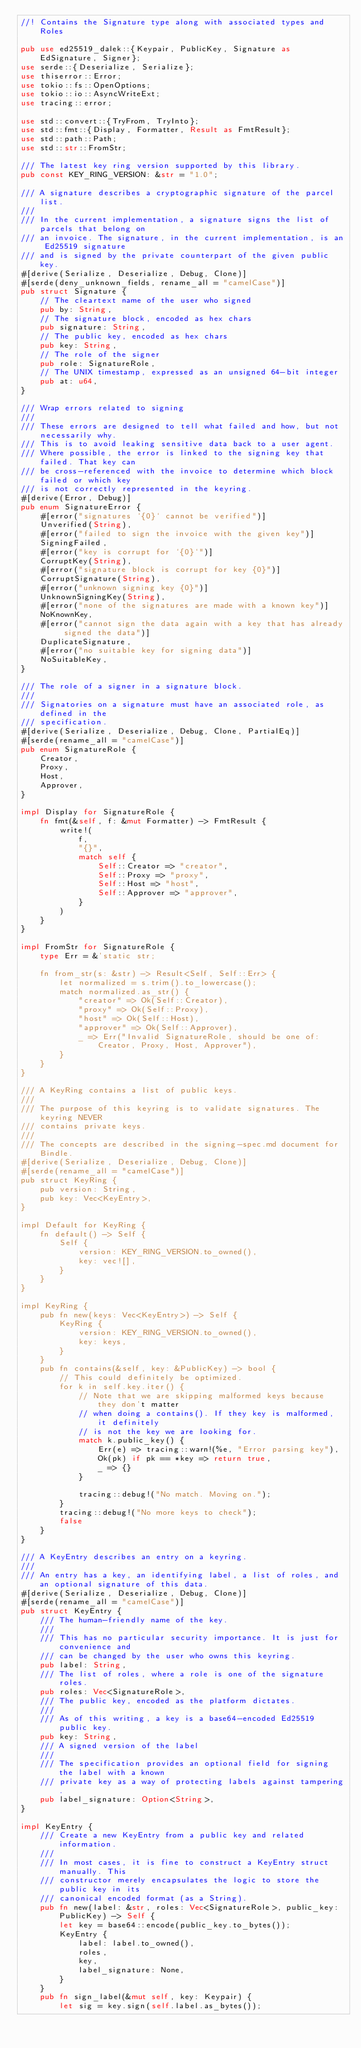Convert code to text. <code><loc_0><loc_0><loc_500><loc_500><_Rust_>//! Contains the Signature type along with associated types and Roles

pub use ed25519_dalek::{Keypair, PublicKey, Signature as EdSignature, Signer};
use serde::{Deserialize, Serialize};
use thiserror::Error;
use tokio::fs::OpenOptions;
use tokio::io::AsyncWriteExt;
use tracing::error;

use std::convert::{TryFrom, TryInto};
use std::fmt::{Display, Formatter, Result as FmtResult};
use std::path::Path;
use std::str::FromStr;

/// The latest key ring version supported by this library.
pub const KEY_RING_VERSION: &str = "1.0";

/// A signature describes a cryptographic signature of the parcel list.
///
/// In the current implementation, a signature signs the list of parcels that belong on
/// an invoice. The signature, in the current implementation, is an Ed25519 signature
/// and is signed by the private counterpart of the given public key.
#[derive(Serialize, Deserialize, Debug, Clone)]
#[serde(deny_unknown_fields, rename_all = "camelCase")]
pub struct Signature {
    // The cleartext name of the user who signed
    pub by: String,
    // The signature block, encoded as hex chars
    pub signature: String,
    // The public key, encoded as hex chars
    pub key: String,
    // The role of the signer
    pub role: SignatureRole,
    // The UNIX timestamp, expressed as an unsigned 64-bit integer
    pub at: u64,
}

/// Wrap errors related to signing
///
/// These errors are designed to tell what failed and how, but not necessarily why.
/// This is to avoid leaking sensitive data back to a user agent.
/// Where possible, the error is linked to the signing key that failed. That key can
/// be cross-referenced with the invoice to determine which block failed or which key
/// is not correctly represented in the keyring.
#[derive(Error, Debug)]
pub enum SignatureError {
    #[error("signatures `{0}` cannot be verified")]
    Unverified(String),
    #[error("failed to sign the invoice with the given key")]
    SigningFailed,
    #[error("key is corrupt for `{0}`")]
    CorruptKey(String),
    #[error("signature block is corrupt for key {0}")]
    CorruptSignature(String),
    #[error("unknown signing key {0}")]
    UnknownSigningKey(String),
    #[error("none of the signatures are made with a known key")]
    NoKnownKey,
    #[error("cannot sign the data again with a key that has already signed the data")]
    DuplicateSignature,
    #[error("no suitable key for signing data")]
    NoSuitableKey,
}

/// The role of a signer in a signature block.
///
/// Signatories on a signature must have an associated role, as defined in the
/// specification.
#[derive(Serialize, Deserialize, Debug, Clone, PartialEq)]
#[serde(rename_all = "camelCase")]
pub enum SignatureRole {
    Creator,
    Proxy,
    Host,
    Approver,
}

impl Display for SignatureRole {
    fn fmt(&self, f: &mut Formatter) -> FmtResult {
        write!(
            f,
            "{}",
            match self {
                Self::Creator => "creator",
                Self::Proxy => "proxy",
                Self::Host => "host",
                Self::Approver => "approver",
            }
        )
    }
}

impl FromStr for SignatureRole {
    type Err = &'static str;

    fn from_str(s: &str) -> Result<Self, Self::Err> {
        let normalized = s.trim().to_lowercase();
        match normalized.as_str() {
            "creator" => Ok(Self::Creator),
            "proxy" => Ok(Self::Proxy),
            "host" => Ok(Self::Host),
            "approver" => Ok(Self::Approver),
            _ => Err("Invalid SignatureRole, should be one of: Creator, Proxy, Host, Approver"),
        }
    }
}

/// A KeyRing contains a list of public keys.
///
/// The purpose of this keyring is to validate signatures. The keyring NEVER
/// contains private keys.
///
/// The concepts are described in the signing-spec.md document for Bindle.
#[derive(Serialize, Deserialize, Debug, Clone)]
#[serde(rename_all = "camelCase")]
pub struct KeyRing {
    pub version: String,
    pub key: Vec<KeyEntry>,
}

impl Default for KeyRing {
    fn default() -> Self {
        Self {
            version: KEY_RING_VERSION.to_owned(),
            key: vec![],
        }
    }
}

impl KeyRing {
    pub fn new(keys: Vec<KeyEntry>) -> Self {
        KeyRing {
            version: KEY_RING_VERSION.to_owned(),
            key: keys,
        }
    }
    pub fn contains(&self, key: &PublicKey) -> bool {
        // This could definitely be optimized.
        for k in self.key.iter() {
            // Note that we are skipping malformed keys because they don't matter
            // when doing a contains(). If they key is malformed, it definitely
            // is not the key we are looking for.
            match k.public_key() {
                Err(e) => tracing::warn!(%e, "Error parsing key"),
                Ok(pk) if pk == *key => return true,
                _ => {}
            }

            tracing::debug!("No match. Moving on.");
        }
        tracing::debug!("No more keys to check");
        false
    }
}

/// A KeyEntry describes an entry on a keyring.
///
/// An entry has a key, an identifying label, a list of roles, and an optional signature of this data.
#[derive(Serialize, Deserialize, Debug, Clone)]
#[serde(rename_all = "camelCase")]
pub struct KeyEntry {
    /// The human-friendly name of the key.
    ///
    /// This has no particular security importance. It is just for convenience and
    /// can be changed by the user who owns this keyring.
    pub label: String,
    /// The list of roles, where a role is one of the signature roles.
    pub roles: Vec<SignatureRole>,
    /// The public key, encoded as the platform dictates.
    ///
    /// As of this writing, a key is a base64-encoded Ed25519 public key.
    pub key: String,
    /// A signed version of the label
    ///
    /// The specification provides an optional field for signing the label with a known
    /// private key as a way of protecting labels against tampering.
    pub label_signature: Option<String>,
}

impl KeyEntry {
    /// Create a new KeyEntry from a public key and related information.
    ///
    /// In most cases, it is fine to construct a KeyEntry struct manually. This
    /// constructor merely encapsulates the logic to store the public key in its
    /// canonical encoded format (as a String).
    pub fn new(label: &str, roles: Vec<SignatureRole>, public_key: PublicKey) -> Self {
        let key = base64::encode(public_key.to_bytes());
        KeyEntry {
            label: label.to_owned(),
            roles,
            key,
            label_signature: None,
        }
    }
    pub fn sign_label(&mut self, key: Keypair) {
        let sig = key.sign(self.label.as_bytes());</code> 